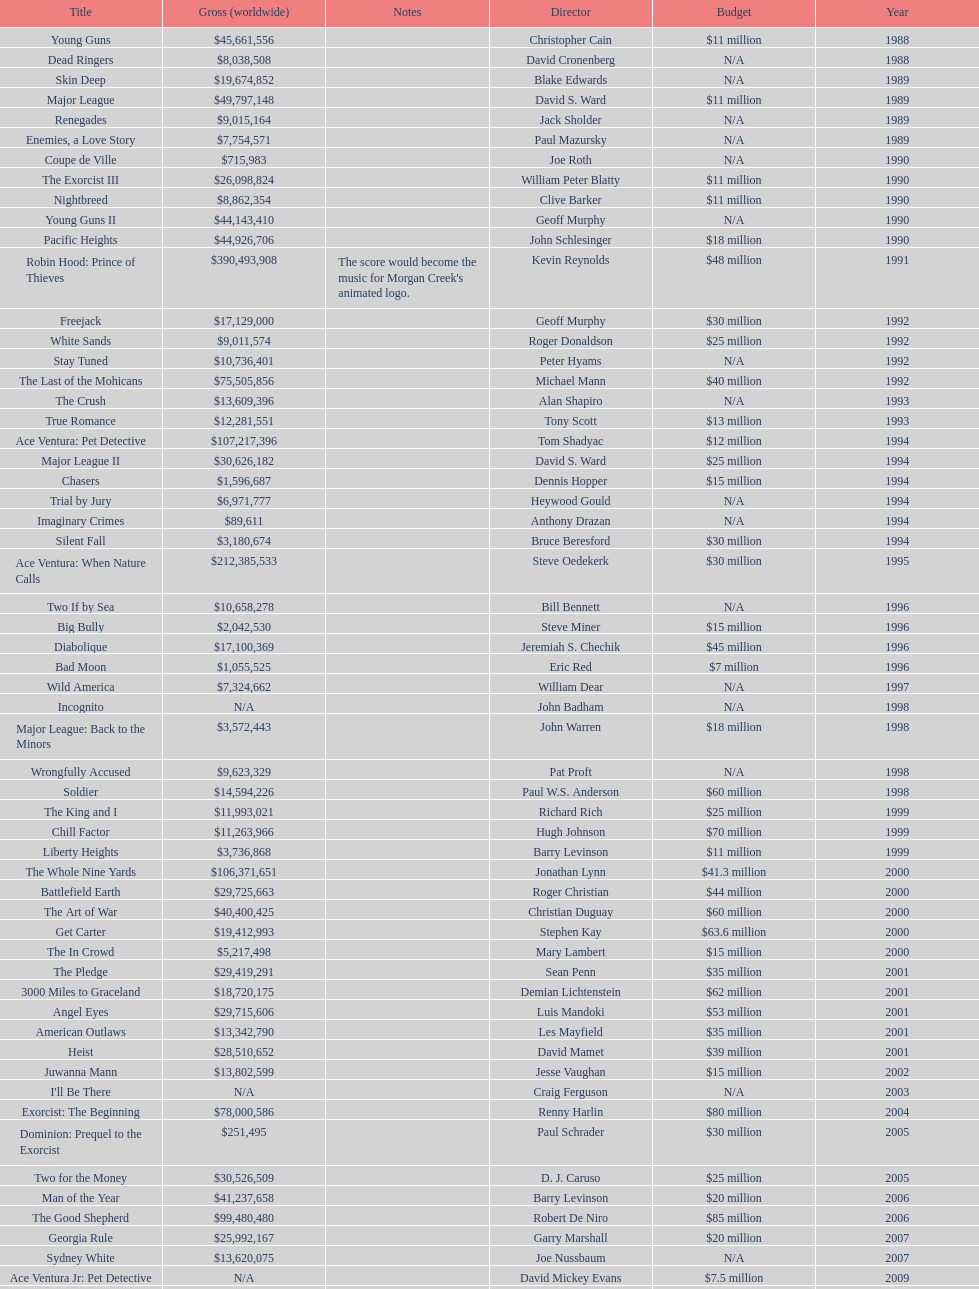How many films were there in 1990? 5. 